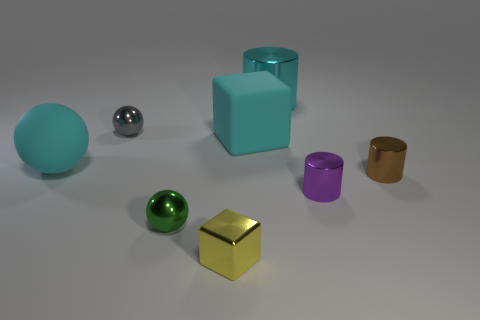Subtract all green shiny balls. How many balls are left? 2 Subtract 1 cylinders. How many cylinders are left? 2 Add 1 cyan spheres. How many objects exist? 9 Subtract all spheres. How many objects are left? 5 Subtract all gray cylinders. Subtract all gray spheres. How many cylinders are left? 3 Add 4 tiny gray balls. How many tiny gray balls exist? 5 Subtract 0 blue balls. How many objects are left? 8 Subtract all brown metal things. Subtract all tiny purple cylinders. How many objects are left? 6 Add 1 small yellow things. How many small yellow things are left? 2 